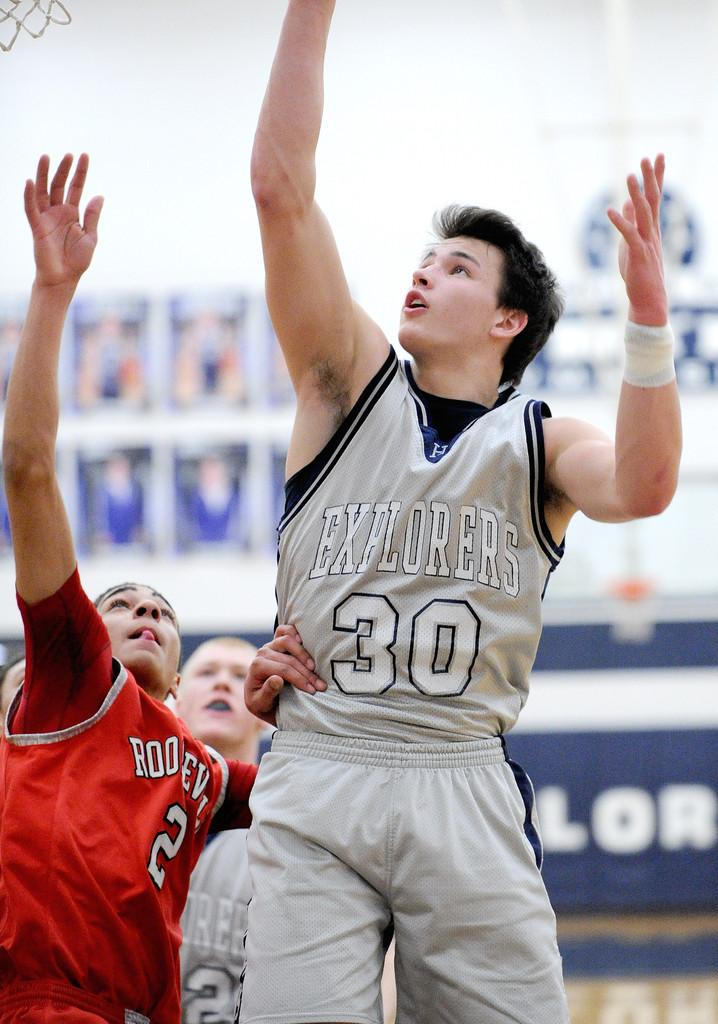<image>
Create a compact narrative representing the image presented. A basketball player wearing an Explorers jersey shoots a basket. 